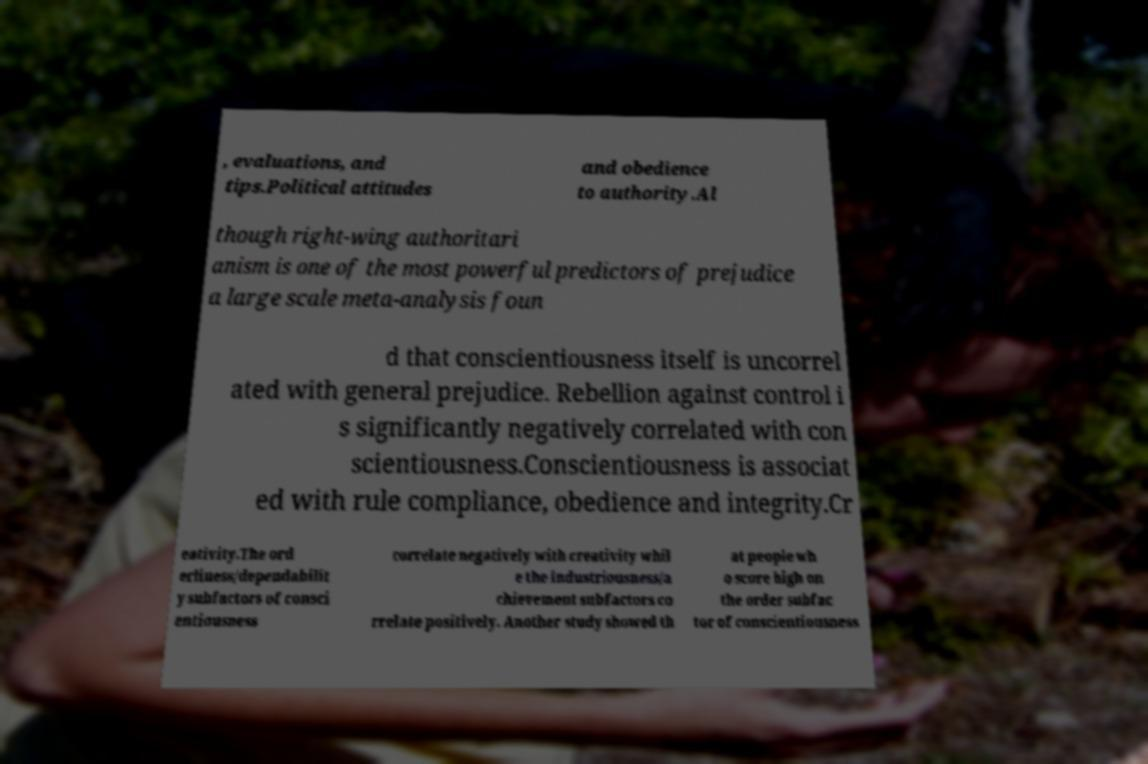Please read and relay the text visible in this image. What does it say? , evaluations, and tips.Political attitudes and obedience to authority.Al though right-wing authoritari anism is one of the most powerful predictors of prejudice a large scale meta-analysis foun d that conscientiousness itself is uncorrel ated with general prejudice. Rebellion against control i s significantly negatively correlated with con scientiousness.Conscientiousness is associat ed with rule compliance, obedience and integrity.Cr eativity.The ord erliness/dependabilit y subfactors of consci entiousness correlate negatively with creativity whil e the industriousness/a chievement subfactors co rrelate positively. Another study showed th at people wh o score high on the order subfac tor of conscientiousness 